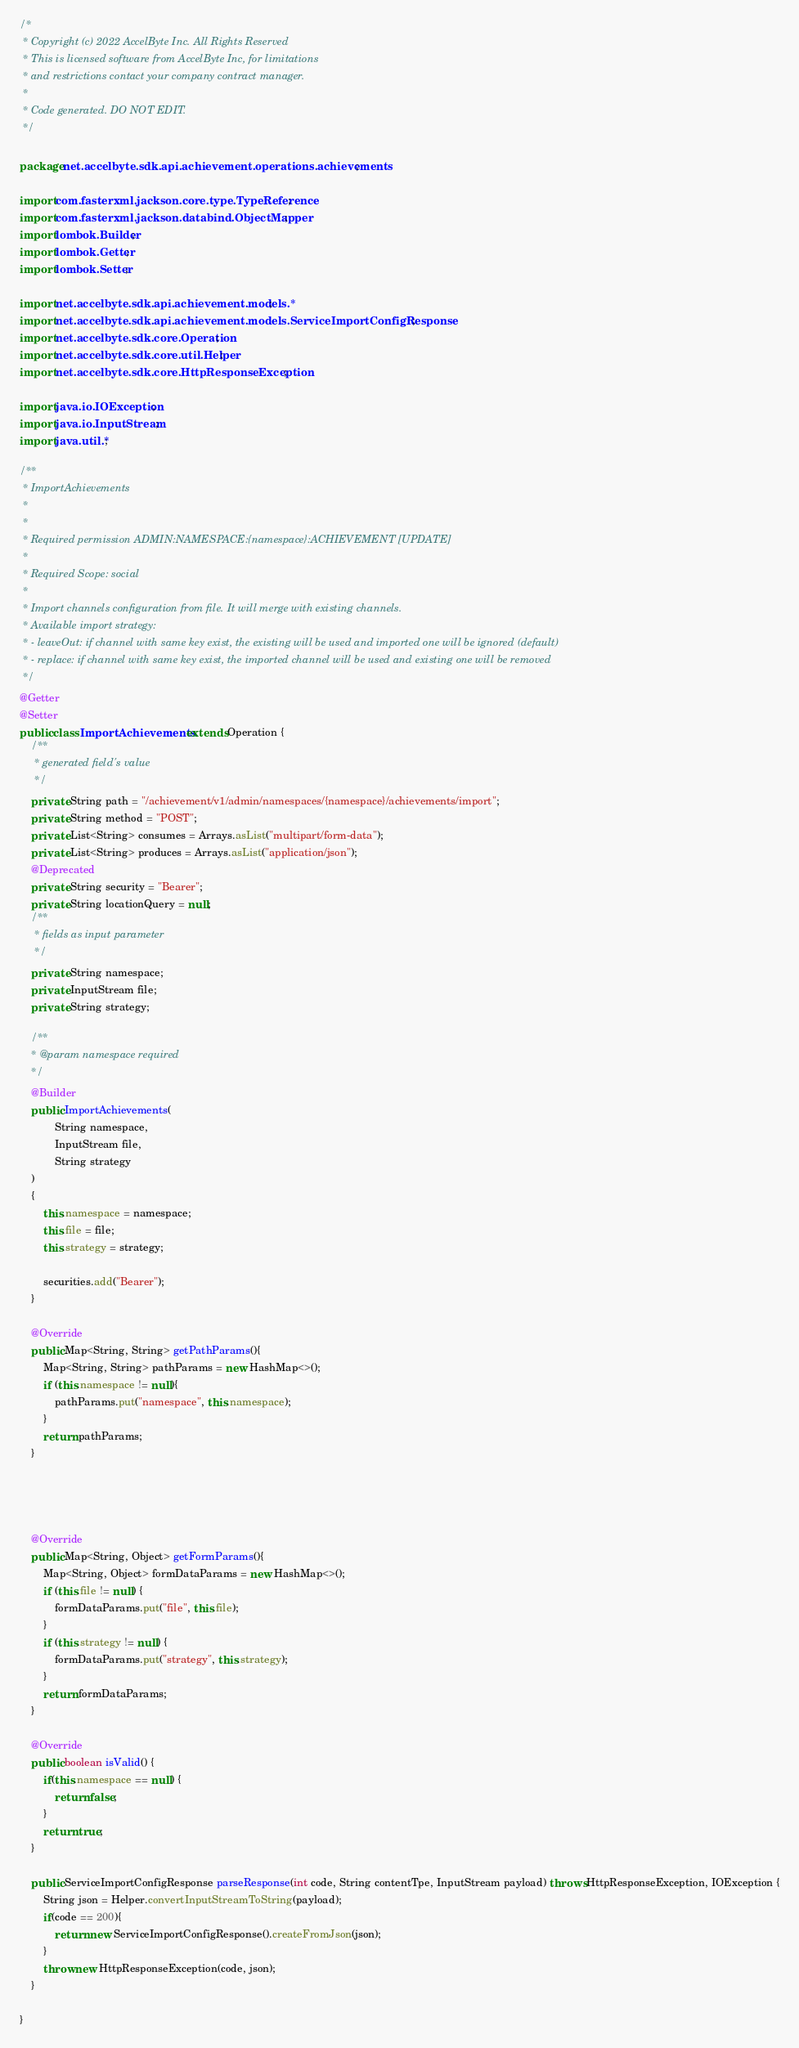Convert code to text. <code><loc_0><loc_0><loc_500><loc_500><_Java_>/*
 * Copyright (c) 2022 AccelByte Inc. All Rights Reserved
 * This is licensed software from AccelByte Inc, for limitations
 * and restrictions contact your company contract manager.
 *
 * Code generated. DO NOT EDIT.
 */

package net.accelbyte.sdk.api.achievement.operations.achievements;

import com.fasterxml.jackson.core.type.TypeReference;
import com.fasterxml.jackson.databind.ObjectMapper;
import lombok.Builder;
import lombok.Getter;
import lombok.Setter;

import net.accelbyte.sdk.api.achievement.models.*;
import net.accelbyte.sdk.api.achievement.models.ServiceImportConfigResponse;
import net.accelbyte.sdk.core.Operation;
import net.accelbyte.sdk.core.util.Helper;
import net.accelbyte.sdk.core.HttpResponseException;

import java.io.IOException;
import java.io.InputStream;
import java.util.*;

/**
 * ImportAchievements
 *
 * 
 * Required permission ADMIN:NAMESPACE:{namespace}:ACHIEVEMENT [UPDATE]
 * 
 * Required Scope: social
 * 
 * Import channels configuration from file. It will merge with existing channels.
 * Available import strategy:
 * - leaveOut: if channel with same key exist, the existing will be used and imported one will be ignored (default)
 * - replace: if channel with same key exist, the imported channel will be used and existing one will be removed
 */
@Getter
@Setter
public class ImportAchievements extends Operation {
    /**
     * generated field's value
     */
    private String path = "/achievement/v1/admin/namespaces/{namespace}/achievements/import";
    private String method = "POST";
    private List<String> consumes = Arrays.asList("multipart/form-data");
    private List<String> produces = Arrays.asList("application/json");
    @Deprecated
    private String security = "Bearer";
    private String locationQuery = null;
    /**
     * fields as input parameter
     */
    private String namespace;
    private InputStream file;
    private String strategy;

    /**
    * @param namespace required
    */
    @Builder
    public ImportAchievements(
            String namespace,
            InputStream file,
            String strategy
    )
    {
        this.namespace = namespace;
        this.file = file;
        this.strategy = strategy;
        
        securities.add("Bearer");
    }

    @Override
    public Map<String, String> getPathParams(){
        Map<String, String> pathParams = new HashMap<>();
        if (this.namespace != null){
            pathParams.put("namespace", this.namespace);
        }
        return pathParams;
    }




    @Override
    public Map<String, Object> getFormParams(){
        Map<String, Object> formDataParams = new HashMap<>();
        if (this.file != null) {
            formDataParams.put("file", this.file);
        }
        if (this.strategy != null) {
            formDataParams.put("strategy", this.strategy);
        }
        return formDataParams;
    }

    @Override
    public boolean isValid() {
        if(this.namespace == null) {
            return false;
        }
        return true;
    }

    public ServiceImportConfigResponse parseResponse(int code, String contentTpe, InputStream payload) throws HttpResponseException, IOException {
        String json = Helper.convertInputStreamToString(payload);
        if(code == 200){
            return new ServiceImportConfigResponse().createFromJson(json);
        }
        throw new HttpResponseException(code, json);
    }

}</code> 